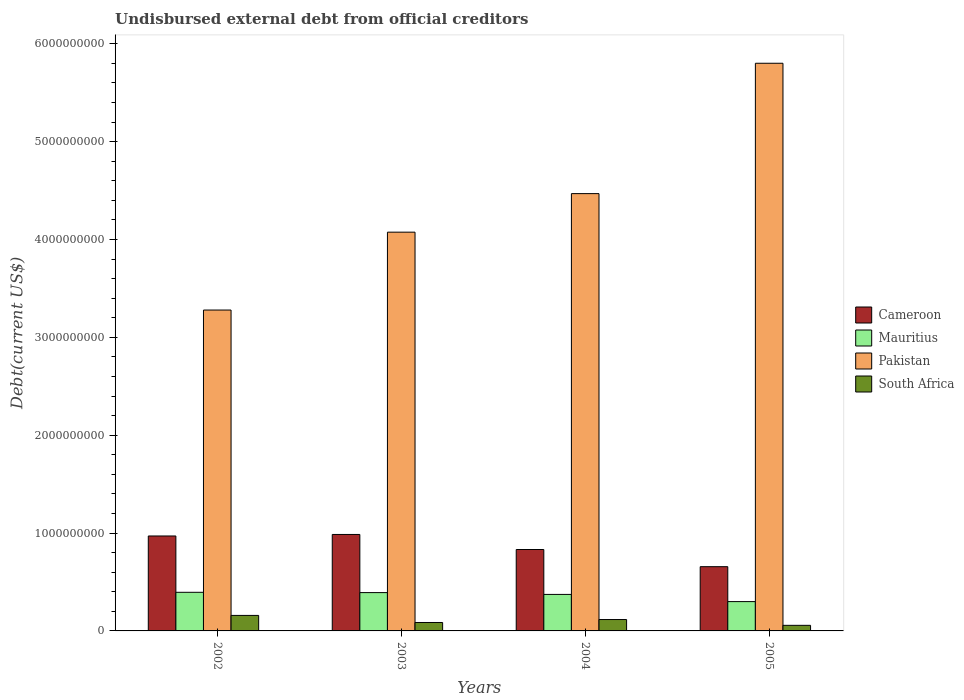How many different coloured bars are there?
Ensure brevity in your answer.  4. Are the number of bars per tick equal to the number of legend labels?
Offer a very short reply. Yes. Are the number of bars on each tick of the X-axis equal?
Your answer should be compact. Yes. How many bars are there on the 4th tick from the right?
Your answer should be compact. 4. What is the label of the 3rd group of bars from the left?
Give a very brief answer. 2004. What is the total debt in Pakistan in 2004?
Keep it short and to the point. 4.47e+09. Across all years, what is the maximum total debt in South Africa?
Make the answer very short. 1.59e+08. Across all years, what is the minimum total debt in Cameroon?
Offer a terse response. 6.57e+08. What is the total total debt in South Africa in the graph?
Offer a terse response. 4.18e+08. What is the difference between the total debt in Cameroon in 2003 and that in 2004?
Keep it short and to the point. 1.54e+08. What is the difference between the total debt in Cameroon in 2003 and the total debt in Mauritius in 2002?
Give a very brief answer. 5.91e+08. What is the average total debt in Cameroon per year?
Keep it short and to the point. 8.61e+08. In the year 2004, what is the difference between the total debt in Mauritius and total debt in Pakistan?
Provide a succinct answer. -4.10e+09. In how many years, is the total debt in Pakistan greater than 1200000000 US$?
Keep it short and to the point. 4. What is the ratio of the total debt in Pakistan in 2002 to that in 2003?
Ensure brevity in your answer.  0.8. Is the difference between the total debt in Mauritius in 2002 and 2003 greater than the difference between the total debt in Pakistan in 2002 and 2003?
Offer a terse response. Yes. What is the difference between the highest and the second highest total debt in Mauritius?
Ensure brevity in your answer.  2.97e+06. What is the difference between the highest and the lowest total debt in South Africa?
Provide a short and direct response. 1.02e+08. Is it the case that in every year, the sum of the total debt in South Africa and total debt in Cameroon is greater than the sum of total debt in Mauritius and total debt in Pakistan?
Your answer should be compact. No. What does the 1st bar from the left in 2002 represents?
Your answer should be very brief. Cameroon. What does the 2nd bar from the right in 2003 represents?
Give a very brief answer. Pakistan. How many bars are there?
Keep it short and to the point. 16. How many years are there in the graph?
Provide a succinct answer. 4. What is the difference between two consecutive major ticks on the Y-axis?
Make the answer very short. 1.00e+09. Does the graph contain grids?
Your response must be concise. No. Where does the legend appear in the graph?
Make the answer very short. Center right. How are the legend labels stacked?
Ensure brevity in your answer.  Vertical. What is the title of the graph?
Your answer should be very brief. Undisbursed external debt from official creditors. Does "Swaziland" appear as one of the legend labels in the graph?
Provide a short and direct response. No. What is the label or title of the X-axis?
Ensure brevity in your answer.  Years. What is the label or title of the Y-axis?
Provide a short and direct response. Debt(current US$). What is the Debt(current US$) in Cameroon in 2002?
Provide a short and direct response. 9.70e+08. What is the Debt(current US$) in Mauritius in 2002?
Your answer should be compact. 3.95e+08. What is the Debt(current US$) in Pakistan in 2002?
Ensure brevity in your answer.  3.28e+09. What is the Debt(current US$) in South Africa in 2002?
Your response must be concise. 1.59e+08. What is the Debt(current US$) of Cameroon in 2003?
Your response must be concise. 9.86e+08. What is the Debt(current US$) in Mauritius in 2003?
Give a very brief answer. 3.92e+08. What is the Debt(current US$) in Pakistan in 2003?
Your answer should be compact. 4.07e+09. What is the Debt(current US$) of South Africa in 2003?
Provide a short and direct response. 8.62e+07. What is the Debt(current US$) in Cameroon in 2004?
Make the answer very short. 8.32e+08. What is the Debt(current US$) of Mauritius in 2004?
Offer a terse response. 3.73e+08. What is the Debt(current US$) of Pakistan in 2004?
Ensure brevity in your answer.  4.47e+09. What is the Debt(current US$) in South Africa in 2004?
Give a very brief answer. 1.16e+08. What is the Debt(current US$) in Cameroon in 2005?
Provide a short and direct response. 6.57e+08. What is the Debt(current US$) in Mauritius in 2005?
Give a very brief answer. 3.00e+08. What is the Debt(current US$) of Pakistan in 2005?
Offer a terse response. 5.80e+09. What is the Debt(current US$) of South Africa in 2005?
Offer a very short reply. 5.70e+07. Across all years, what is the maximum Debt(current US$) of Cameroon?
Ensure brevity in your answer.  9.86e+08. Across all years, what is the maximum Debt(current US$) of Mauritius?
Your answer should be very brief. 3.95e+08. Across all years, what is the maximum Debt(current US$) of Pakistan?
Your answer should be compact. 5.80e+09. Across all years, what is the maximum Debt(current US$) of South Africa?
Offer a very short reply. 1.59e+08. Across all years, what is the minimum Debt(current US$) of Cameroon?
Provide a succinct answer. 6.57e+08. Across all years, what is the minimum Debt(current US$) of Mauritius?
Ensure brevity in your answer.  3.00e+08. Across all years, what is the minimum Debt(current US$) in Pakistan?
Give a very brief answer. 3.28e+09. Across all years, what is the minimum Debt(current US$) in South Africa?
Give a very brief answer. 5.70e+07. What is the total Debt(current US$) in Cameroon in the graph?
Give a very brief answer. 3.44e+09. What is the total Debt(current US$) of Mauritius in the graph?
Provide a short and direct response. 1.46e+09. What is the total Debt(current US$) of Pakistan in the graph?
Your answer should be compact. 1.76e+1. What is the total Debt(current US$) in South Africa in the graph?
Give a very brief answer. 4.18e+08. What is the difference between the Debt(current US$) of Cameroon in 2002 and that in 2003?
Make the answer very short. -1.55e+07. What is the difference between the Debt(current US$) in Mauritius in 2002 and that in 2003?
Offer a terse response. 2.97e+06. What is the difference between the Debt(current US$) in Pakistan in 2002 and that in 2003?
Keep it short and to the point. -7.96e+08. What is the difference between the Debt(current US$) of South Africa in 2002 and that in 2003?
Make the answer very short. 7.24e+07. What is the difference between the Debt(current US$) in Cameroon in 2002 and that in 2004?
Your response must be concise. 1.38e+08. What is the difference between the Debt(current US$) of Mauritius in 2002 and that in 2004?
Ensure brevity in your answer.  2.16e+07. What is the difference between the Debt(current US$) of Pakistan in 2002 and that in 2004?
Offer a terse response. -1.19e+09. What is the difference between the Debt(current US$) in South Africa in 2002 and that in 2004?
Provide a short and direct response. 4.22e+07. What is the difference between the Debt(current US$) in Cameroon in 2002 and that in 2005?
Make the answer very short. 3.14e+08. What is the difference between the Debt(current US$) in Mauritius in 2002 and that in 2005?
Offer a terse response. 9.50e+07. What is the difference between the Debt(current US$) of Pakistan in 2002 and that in 2005?
Ensure brevity in your answer.  -2.52e+09. What is the difference between the Debt(current US$) in South Africa in 2002 and that in 2005?
Ensure brevity in your answer.  1.02e+08. What is the difference between the Debt(current US$) in Cameroon in 2003 and that in 2004?
Your answer should be very brief. 1.54e+08. What is the difference between the Debt(current US$) in Mauritius in 2003 and that in 2004?
Your answer should be very brief. 1.87e+07. What is the difference between the Debt(current US$) in Pakistan in 2003 and that in 2004?
Provide a succinct answer. -3.94e+08. What is the difference between the Debt(current US$) in South Africa in 2003 and that in 2004?
Your response must be concise. -3.02e+07. What is the difference between the Debt(current US$) of Cameroon in 2003 and that in 2005?
Give a very brief answer. 3.29e+08. What is the difference between the Debt(current US$) of Mauritius in 2003 and that in 2005?
Keep it short and to the point. 9.21e+07. What is the difference between the Debt(current US$) in Pakistan in 2003 and that in 2005?
Offer a very short reply. -1.73e+09. What is the difference between the Debt(current US$) of South Africa in 2003 and that in 2005?
Keep it short and to the point. 2.91e+07. What is the difference between the Debt(current US$) of Cameroon in 2004 and that in 2005?
Provide a succinct answer. 1.76e+08. What is the difference between the Debt(current US$) in Mauritius in 2004 and that in 2005?
Offer a very short reply. 7.34e+07. What is the difference between the Debt(current US$) in Pakistan in 2004 and that in 2005?
Provide a succinct answer. -1.33e+09. What is the difference between the Debt(current US$) of South Africa in 2004 and that in 2005?
Make the answer very short. 5.94e+07. What is the difference between the Debt(current US$) of Cameroon in 2002 and the Debt(current US$) of Mauritius in 2003?
Ensure brevity in your answer.  5.79e+08. What is the difference between the Debt(current US$) of Cameroon in 2002 and the Debt(current US$) of Pakistan in 2003?
Offer a terse response. -3.10e+09. What is the difference between the Debt(current US$) of Cameroon in 2002 and the Debt(current US$) of South Africa in 2003?
Keep it short and to the point. 8.84e+08. What is the difference between the Debt(current US$) in Mauritius in 2002 and the Debt(current US$) in Pakistan in 2003?
Make the answer very short. -3.68e+09. What is the difference between the Debt(current US$) in Mauritius in 2002 and the Debt(current US$) in South Africa in 2003?
Offer a terse response. 3.08e+08. What is the difference between the Debt(current US$) in Pakistan in 2002 and the Debt(current US$) in South Africa in 2003?
Your answer should be compact. 3.19e+09. What is the difference between the Debt(current US$) in Cameroon in 2002 and the Debt(current US$) in Mauritius in 2004?
Provide a succinct answer. 5.97e+08. What is the difference between the Debt(current US$) of Cameroon in 2002 and the Debt(current US$) of Pakistan in 2004?
Your answer should be very brief. -3.50e+09. What is the difference between the Debt(current US$) in Cameroon in 2002 and the Debt(current US$) in South Africa in 2004?
Give a very brief answer. 8.54e+08. What is the difference between the Debt(current US$) in Mauritius in 2002 and the Debt(current US$) in Pakistan in 2004?
Provide a short and direct response. -4.07e+09. What is the difference between the Debt(current US$) in Mauritius in 2002 and the Debt(current US$) in South Africa in 2004?
Give a very brief answer. 2.78e+08. What is the difference between the Debt(current US$) in Pakistan in 2002 and the Debt(current US$) in South Africa in 2004?
Ensure brevity in your answer.  3.16e+09. What is the difference between the Debt(current US$) in Cameroon in 2002 and the Debt(current US$) in Mauritius in 2005?
Provide a succinct answer. 6.71e+08. What is the difference between the Debt(current US$) of Cameroon in 2002 and the Debt(current US$) of Pakistan in 2005?
Keep it short and to the point. -4.83e+09. What is the difference between the Debt(current US$) of Cameroon in 2002 and the Debt(current US$) of South Africa in 2005?
Your response must be concise. 9.13e+08. What is the difference between the Debt(current US$) in Mauritius in 2002 and the Debt(current US$) in Pakistan in 2005?
Provide a short and direct response. -5.41e+09. What is the difference between the Debt(current US$) of Mauritius in 2002 and the Debt(current US$) of South Africa in 2005?
Keep it short and to the point. 3.38e+08. What is the difference between the Debt(current US$) in Pakistan in 2002 and the Debt(current US$) in South Africa in 2005?
Provide a succinct answer. 3.22e+09. What is the difference between the Debt(current US$) in Cameroon in 2003 and the Debt(current US$) in Mauritius in 2004?
Give a very brief answer. 6.13e+08. What is the difference between the Debt(current US$) in Cameroon in 2003 and the Debt(current US$) in Pakistan in 2004?
Your answer should be compact. -3.48e+09. What is the difference between the Debt(current US$) of Cameroon in 2003 and the Debt(current US$) of South Africa in 2004?
Your answer should be compact. 8.69e+08. What is the difference between the Debt(current US$) of Mauritius in 2003 and the Debt(current US$) of Pakistan in 2004?
Offer a very short reply. -4.08e+09. What is the difference between the Debt(current US$) in Mauritius in 2003 and the Debt(current US$) in South Africa in 2004?
Your answer should be very brief. 2.75e+08. What is the difference between the Debt(current US$) of Pakistan in 2003 and the Debt(current US$) of South Africa in 2004?
Provide a short and direct response. 3.96e+09. What is the difference between the Debt(current US$) in Cameroon in 2003 and the Debt(current US$) in Mauritius in 2005?
Provide a succinct answer. 6.86e+08. What is the difference between the Debt(current US$) of Cameroon in 2003 and the Debt(current US$) of Pakistan in 2005?
Your answer should be very brief. -4.82e+09. What is the difference between the Debt(current US$) of Cameroon in 2003 and the Debt(current US$) of South Africa in 2005?
Provide a succinct answer. 9.29e+08. What is the difference between the Debt(current US$) of Mauritius in 2003 and the Debt(current US$) of Pakistan in 2005?
Your answer should be compact. -5.41e+09. What is the difference between the Debt(current US$) of Mauritius in 2003 and the Debt(current US$) of South Africa in 2005?
Provide a short and direct response. 3.35e+08. What is the difference between the Debt(current US$) of Pakistan in 2003 and the Debt(current US$) of South Africa in 2005?
Make the answer very short. 4.02e+09. What is the difference between the Debt(current US$) in Cameroon in 2004 and the Debt(current US$) in Mauritius in 2005?
Your answer should be compact. 5.32e+08. What is the difference between the Debt(current US$) in Cameroon in 2004 and the Debt(current US$) in Pakistan in 2005?
Keep it short and to the point. -4.97e+09. What is the difference between the Debt(current US$) in Cameroon in 2004 and the Debt(current US$) in South Africa in 2005?
Ensure brevity in your answer.  7.75e+08. What is the difference between the Debt(current US$) in Mauritius in 2004 and the Debt(current US$) in Pakistan in 2005?
Your answer should be compact. -5.43e+09. What is the difference between the Debt(current US$) of Mauritius in 2004 and the Debt(current US$) of South Africa in 2005?
Ensure brevity in your answer.  3.16e+08. What is the difference between the Debt(current US$) in Pakistan in 2004 and the Debt(current US$) in South Africa in 2005?
Give a very brief answer. 4.41e+09. What is the average Debt(current US$) in Cameroon per year?
Give a very brief answer. 8.61e+08. What is the average Debt(current US$) of Mauritius per year?
Give a very brief answer. 3.65e+08. What is the average Debt(current US$) of Pakistan per year?
Make the answer very short. 4.41e+09. What is the average Debt(current US$) in South Africa per year?
Your answer should be compact. 1.05e+08. In the year 2002, what is the difference between the Debt(current US$) in Cameroon and Debt(current US$) in Mauritius?
Offer a very short reply. 5.76e+08. In the year 2002, what is the difference between the Debt(current US$) of Cameroon and Debt(current US$) of Pakistan?
Make the answer very short. -2.31e+09. In the year 2002, what is the difference between the Debt(current US$) of Cameroon and Debt(current US$) of South Africa?
Provide a succinct answer. 8.12e+08. In the year 2002, what is the difference between the Debt(current US$) in Mauritius and Debt(current US$) in Pakistan?
Your answer should be compact. -2.88e+09. In the year 2002, what is the difference between the Debt(current US$) in Mauritius and Debt(current US$) in South Africa?
Ensure brevity in your answer.  2.36e+08. In the year 2002, what is the difference between the Debt(current US$) in Pakistan and Debt(current US$) in South Africa?
Your answer should be compact. 3.12e+09. In the year 2003, what is the difference between the Debt(current US$) in Cameroon and Debt(current US$) in Mauritius?
Provide a short and direct response. 5.94e+08. In the year 2003, what is the difference between the Debt(current US$) of Cameroon and Debt(current US$) of Pakistan?
Your answer should be very brief. -3.09e+09. In the year 2003, what is the difference between the Debt(current US$) of Cameroon and Debt(current US$) of South Africa?
Ensure brevity in your answer.  9.00e+08. In the year 2003, what is the difference between the Debt(current US$) of Mauritius and Debt(current US$) of Pakistan?
Provide a succinct answer. -3.68e+09. In the year 2003, what is the difference between the Debt(current US$) in Mauritius and Debt(current US$) in South Africa?
Provide a short and direct response. 3.05e+08. In the year 2003, what is the difference between the Debt(current US$) in Pakistan and Debt(current US$) in South Africa?
Your response must be concise. 3.99e+09. In the year 2004, what is the difference between the Debt(current US$) of Cameroon and Debt(current US$) of Mauritius?
Your answer should be very brief. 4.59e+08. In the year 2004, what is the difference between the Debt(current US$) of Cameroon and Debt(current US$) of Pakistan?
Your response must be concise. -3.64e+09. In the year 2004, what is the difference between the Debt(current US$) in Cameroon and Debt(current US$) in South Africa?
Provide a succinct answer. 7.16e+08. In the year 2004, what is the difference between the Debt(current US$) in Mauritius and Debt(current US$) in Pakistan?
Offer a very short reply. -4.10e+09. In the year 2004, what is the difference between the Debt(current US$) of Mauritius and Debt(current US$) of South Africa?
Give a very brief answer. 2.57e+08. In the year 2004, what is the difference between the Debt(current US$) in Pakistan and Debt(current US$) in South Africa?
Your answer should be very brief. 4.35e+09. In the year 2005, what is the difference between the Debt(current US$) of Cameroon and Debt(current US$) of Mauritius?
Offer a very short reply. 3.57e+08. In the year 2005, what is the difference between the Debt(current US$) of Cameroon and Debt(current US$) of Pakistan?
Make the answer very short. -5.14e+09. In the year 2005, what is the difference between the Debt(current US$) of Cameroon and Debt(current US$) of South Africa?
Offer a terse response. 5.99e+08. In the year 2005, what is the difference between the Debt(current US$) in Mauritius and Debt(current US$) in Pakistan?
Your answer should be very brief. -5.50e+09. In the year 2005, what is the difference between the Debt(current US$) of Mauritius and Debt(current US$) of South Africa?
Provide a succinct answer. 2.43e+08. In the year 2005, what is the difference between the Debt(current US$) of Pakistan and Debt(current US$) of South Africa?
Your answer should be compact. 5.74e+09. What is the ratio of the Debt(current US$) in Cameroon in 2002 to that in 2003?
Ensure brevity in your answer.  0.98. What is the ratio of the Debt(current US$) of Mauritius in 2002 to that in 2003?
Offer a terse response. 1.01. What is the ratio of the Debt(current US$) in Pakistan in 2002 to that in 2003?
Your response must be concise. 0.8. What is the ratio of the Debt(current US$) of South Africa in 2002 to that in 2003?
Provide a succinct answer. 1.84. What is the ratio of the Debt(current US$) in Cameroon in 2002 to that in 2004?
Offer a very short reply. 1.17. What is the ratio of the Debt(current US$) of Mauritius in 2002 to that in 2004?
Your answer should be compact. 1.06. What is the ratio of the Debt(current US$) of Pakistan in 2002 to that in 2004?
Offer a terse response. 0.73. What is the ratio of the Debt(current US$) of South Africa in 2002 to that in 2004?
Your response must be concise. 1.36. What is the ratio of the Debt(current US$) in Cameroon in 2002 to that in 2005?
Offer a very short reply. 1.48. What is the ratio of the Debt(current US$) of Mauritius in 2002 to that in 2005?
Keep it short and to the point. 1.32. What is the ratio of the Debt(current US$) of Pakistan in 2002 to that in 2005?
Offer a terse response. 0.57. What is the ratio of the Debt(current US$) of South Africa in 2002 to that in 2005?
Provide a short and direct response. 2.78. What is the ratio of the Debt(current US$) in Cameroon in 2003 to that in 2004?
Give a very brief answer. 1.18. What is the ratio of the Debt(current US$) in Mauritius in 2003 to that in 2004?
Ensure brevity in your answer.  1.05. What is the ratio of the Debt(current US$) in Pakistan in 2003 to that in 2004?
Your answer should be compact. 0.91. What is the ratio of the Debt(current US$) in South Africa in 2003 to that in 2004?
Your answer should be very brief. 0.74. What is the ratio of the Debt(current US$) of Cameroon in 2003 to that in 2005?
Offer a very short reply. 1.5. What is the ratio of the Debt(current US$) in Mauritius in 2003 to that in 2005?
Give a very brief answer. 1.31. What is the ratio of the Debt(current US$) of Pakistan in 2003 to that in 2005?
Keep it short and to the point. 0.7. What is the ratio of the Debt(current US$) in South Africa in 2003 to that in 2005?
Provide a short and direct response. 1.51. What is the ratio of the Debt(current US$) of Cameroon in 2004 to that in 2005?
Your response must be concise. 1.27. What is the ratio of the Debt(current US$) in Mauritius in 2004 to that in 2005?
Give a very brief answer. 1.25. What is the ratio of the Debt(current US$) in Pakistan in 2004 to that in 2005?
Make the answer very short. 0.77. What is the ratio of the Debt(current US$) of South Africa in 2004 to that in 2005?
Make the answer very short. 2.04. What is the difference between the highest and the second highest Debt(current US$) of Cameroon?
Your answer should be compact. 1.55e+07. What is the difference between the highest and the second highest Debt(current US$) in Mauritius?
Keep it short and to the point. 2.97e+06. What is the difference between the highest and the second highest Debt(current US$) in Pakistan?
Make the answer very short. 1.33e+09. What is the difference between the highest and the second highest Debt(current US$) in South Africa?
Provide a succinct answer. 4.22e+07. What is the difference between the highest and the lowest Debt(current US$) in Cameroon?
Offer a very short reply. 3.29e+08. What is the difference between the highest and the lowest Debt(current US$) in Mauritius?
Offer a terse response. 9.50e+07. What is the difference between the highest and the lowest Debt(current US$) in Pakistan?
Keep it short and to the point. 2.52e+09. What is the difference between the highest and the lowest Debt(current US$) of South Africa?
Keep it short and to the point. 1.02e+08. 